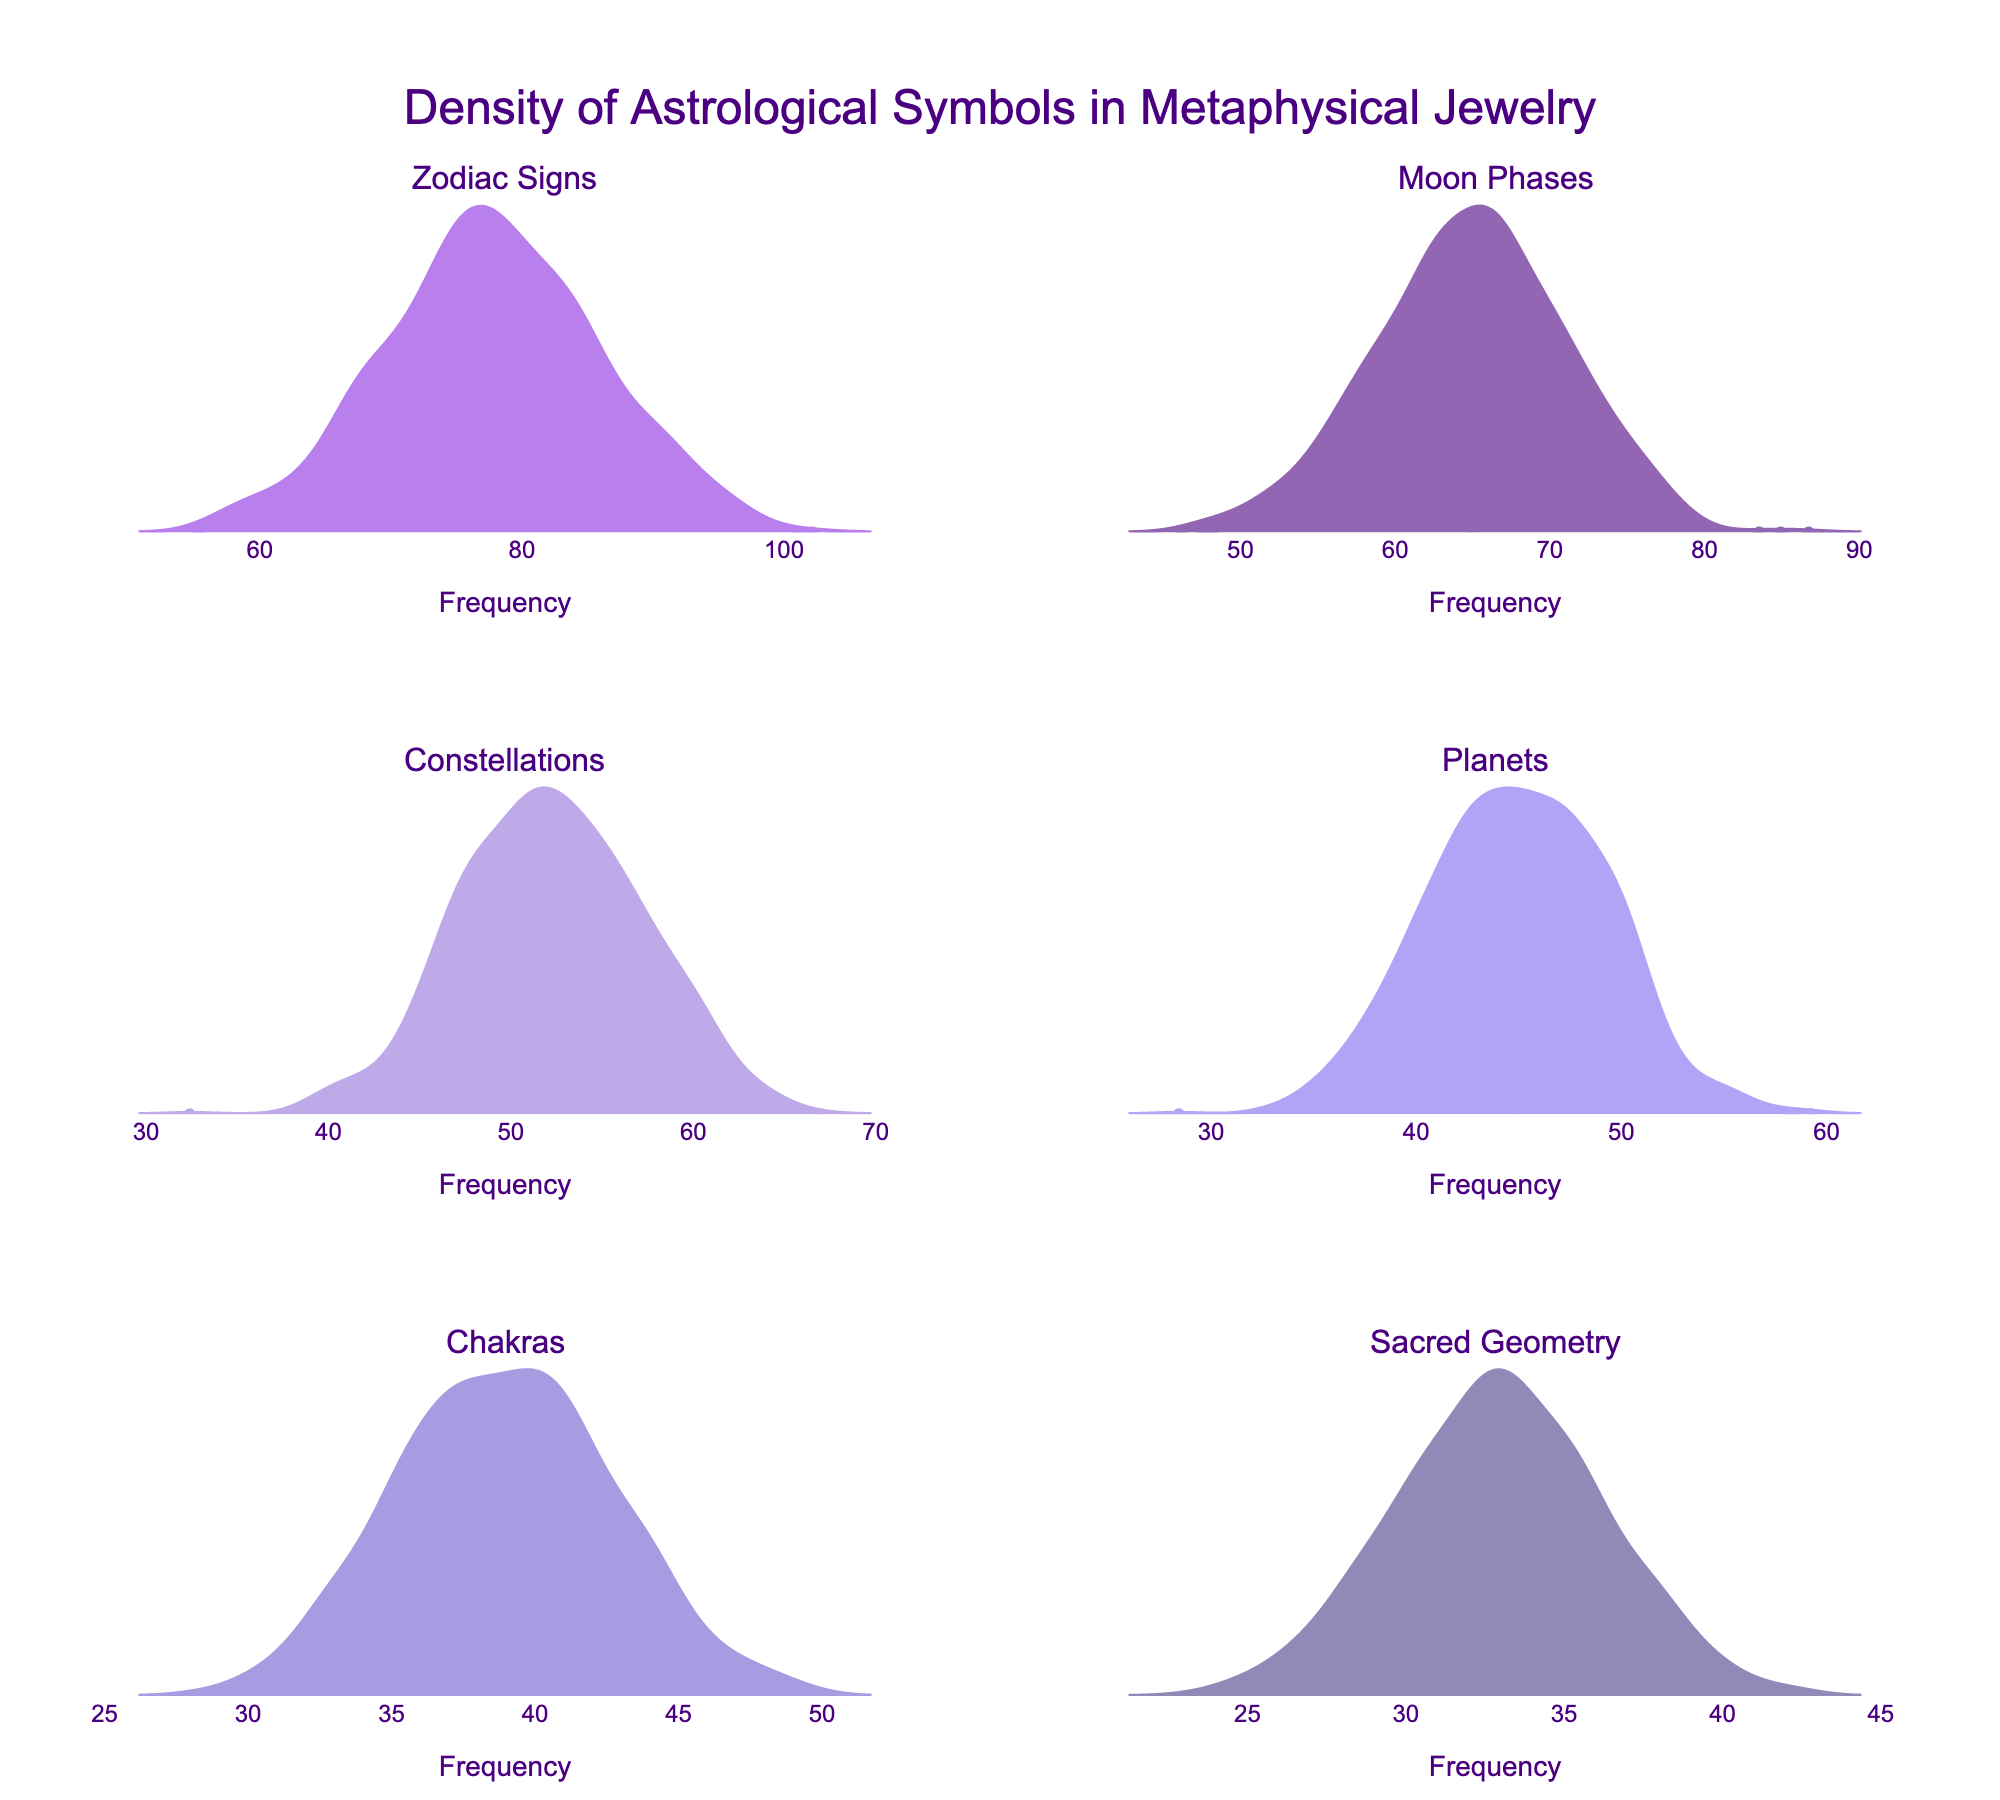What's the most frequently occurring astrological symbol in metaphysical jewelry designs according to the plot? By observing the titles and densities of the plots, the symbol with the highest density curve represents the highest frequency. "Zodiac Signs" has the most intense peak with a frequency of 78, making it the most frequent.
Answer: Zodiac Signs What is the average frequency of "Moon Phases" and "Constellations"? The frequency for "Moon Phases" is 65 and for "Constellations" is 52. To find the average: (65 + 52) / 2 = 117 / 2 = 58.5.
Answer: 58.5 Which symbol has a lower frequency: "Planets" or "Chakras"? By comparing the density plots of "Planets" and "Chakras," the frequency for "Planets" is 45, and for "Chakras" it is 39. Clearly, 39 is less than 45.
Answer: Chakras How many symbols have a frequency greater than 50? Observing the density plots, symbols with frequencies greater than 50 are "Zodiac Signs," "Moon Phases," and "Constellations." There are 3 symbols in total.
Answer: 3 Between "Sacred Geometry" and "Cosmic Elements," which symbol shows a higher density? By comparing the density plots of both symbols, "Sacred Geometry" has a frequency of 33, while "Cosmic Elements" has 28. Therefore, "Sacred Geometry" has a higher density curve.
Answer: Sacred Geometry Calculate the total frequency of the symbols displayed in the plots. The symbols displayed are "Zodiac Signs," "Moon Phases," "Constellations," "Planets," "Chakras," and "Sacred Geometry" with frequencies 78, 65, 52, 45, 39, and 33 respectively. Summing these frequencies: 78 + 65 + 52 + 45 + 39 + 33 = 312.
Answer: 312 What trend can you observe from the frequencies of the symbols in the density plots? The density plots show that as we move from "Zodiac Signs" to "Sacred Geometry," the frequency of symbols decreases steadily. Each subsequent plot from left to right and top to bottom shows a decreasing peak, indicating a lower frequency.
Answer: Decreasing trend Among the symbols shown, which has the smallest variance based on the density plot? The density plots' spread helps estimate variance. "Sacred Geometry" has a narrower spread compared to others like "Zodiac Signs," indicating it has the smallest variance.
Answer: Sacred Geometry 